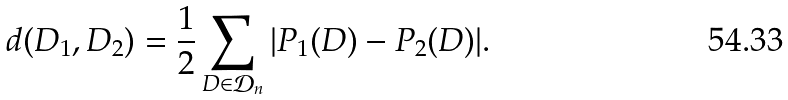Convert formula to latex. <formula><loc_0><loc_0><loc_500><loc_500>d ( D _ { 1 } , D _ { 2 } ) = \frac { 1 } { 2 } \sum _ { D \in \mathcal { D } _ { n } } | P _ { 1 } ( D ) - P _ { 2 } ( D ) | .</formula> 